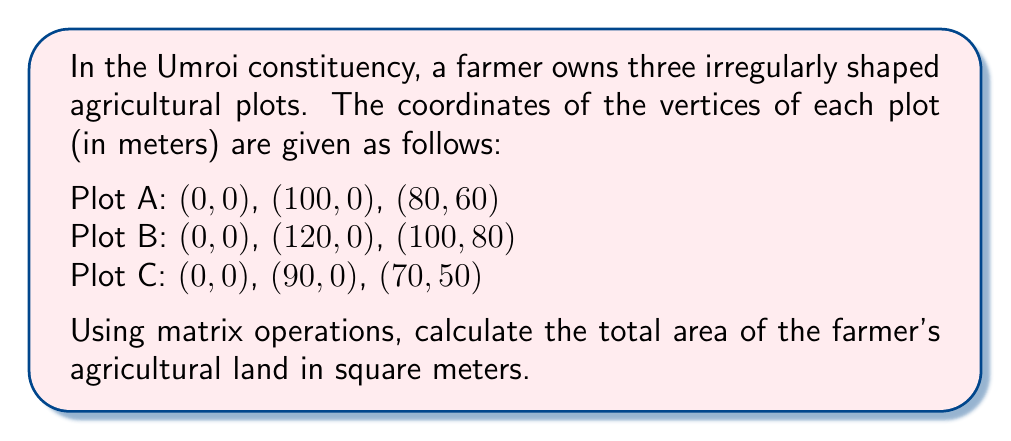Can you solve this math problem? To solve this problem, we'll use the matrix method for calculating the area of a triangle. For each plot:

1. Create a matrix with the coordinates of the three vertices.
2. Add a column of 1's to the matrix.
3. Calculate the determinant of the resulting matrix.
4. Take half of the absolute value of the determinant to get the area.

Let's solve for each plot:

Plot A:
$$A = \frac{1}{2} \left|\det\begin{pmatrix}
0 & 0 & 1 \\
100 & 0 & 1 \\
80 & 60 & 1
\end{pmatrix}\right|$$

$$A = \frac{1}{2} |0 - 0 + 6000 - 0| = 3000 \text{ m}^2$$

Plot B:
$$B = \frac{1}{2} \left|\det\begin{pmatrix}
0 & 0 & 1 \\
120 & 0 & 1 \\
100 & 80 & 1
\end{pmatrix}\right|$$

$$B = \frac{1}{2} |0 - 0 + 9600 - 0| = 4800 \text{ m}^2$$

Plot C:
$$C = \frac{1}{2} \left|\det\begin{pmatrix}
0 & 0 & 1 \\
90 & 0 & 1 \\
70 & 50 & 1
\end{pmatrix}\right|$$

$$C = \frac{1}{2} |0 - 0 + 4500 - 0| = 2250 \text{ m}^2$$

The total area is the sum of the areas of all three plots:

Total Area = Area of Plot A + Area of Plot B + Area of Plot C
Total Area = 3000 + 4800 + 2250 = 10,050 m²
Answer: The total area of the farmer's agricultural land is 10,050 square meters. 